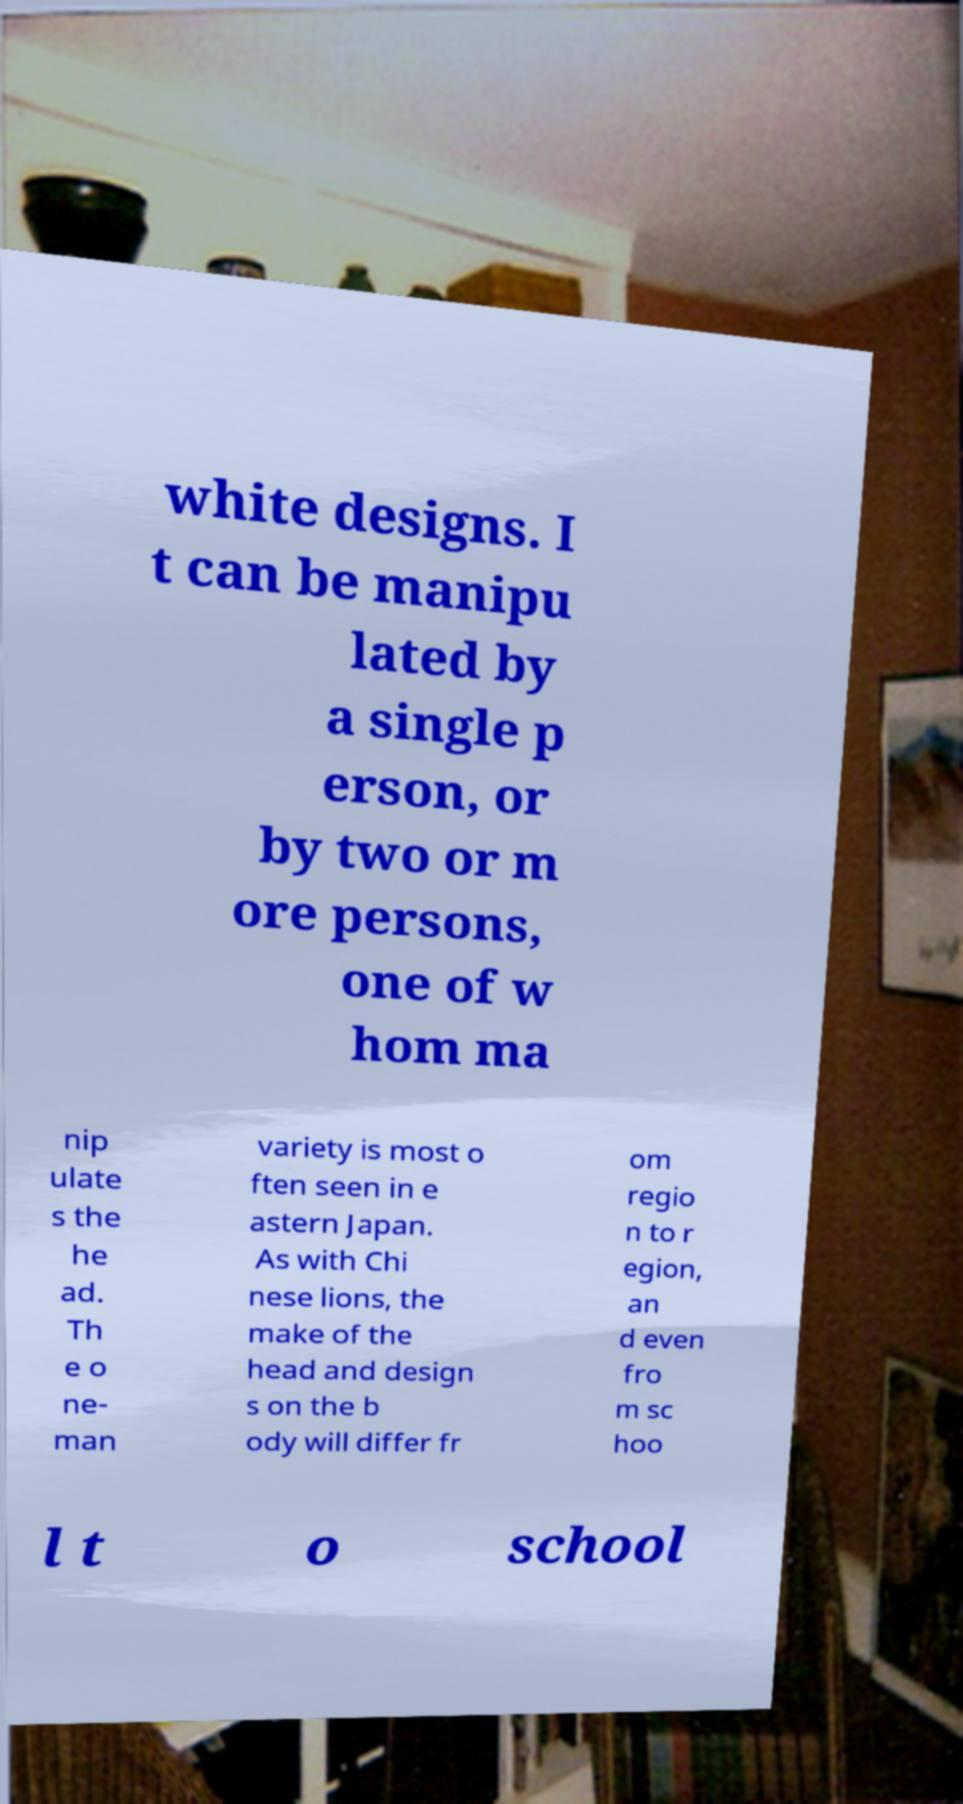What messages or text are displayed in this image? I need them in a readable, typed format. white designs. I t can be manipu lated by a single p erson, or by two or m ore persons, one of w hom ma nip ulate s the he ad. Th e o ne- man variety is most o ften seen in e astern Japan. As with Chi nese lions, the make of the head and design s on the b ody will differ fr om regio n to r egion, an d even fro m sc hoo l t o school 